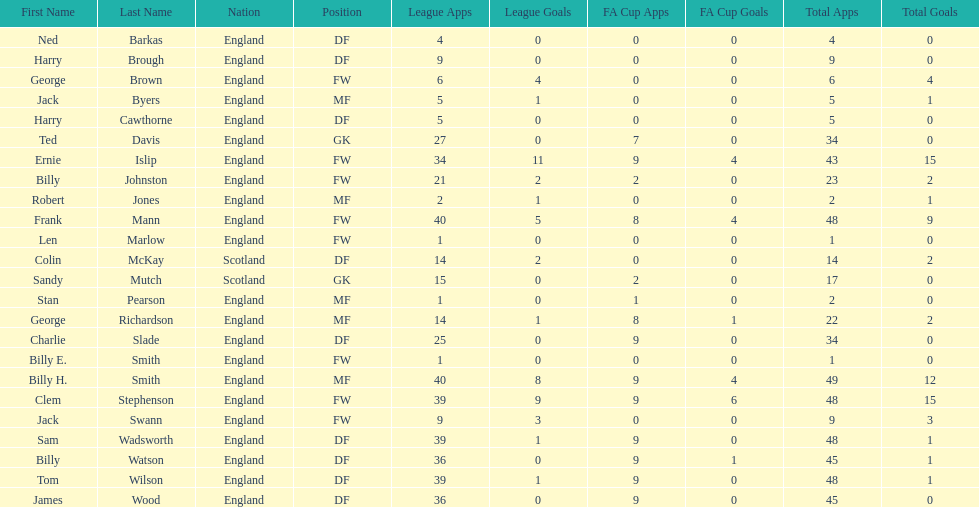What is the first name listed? Ned Barkas. 